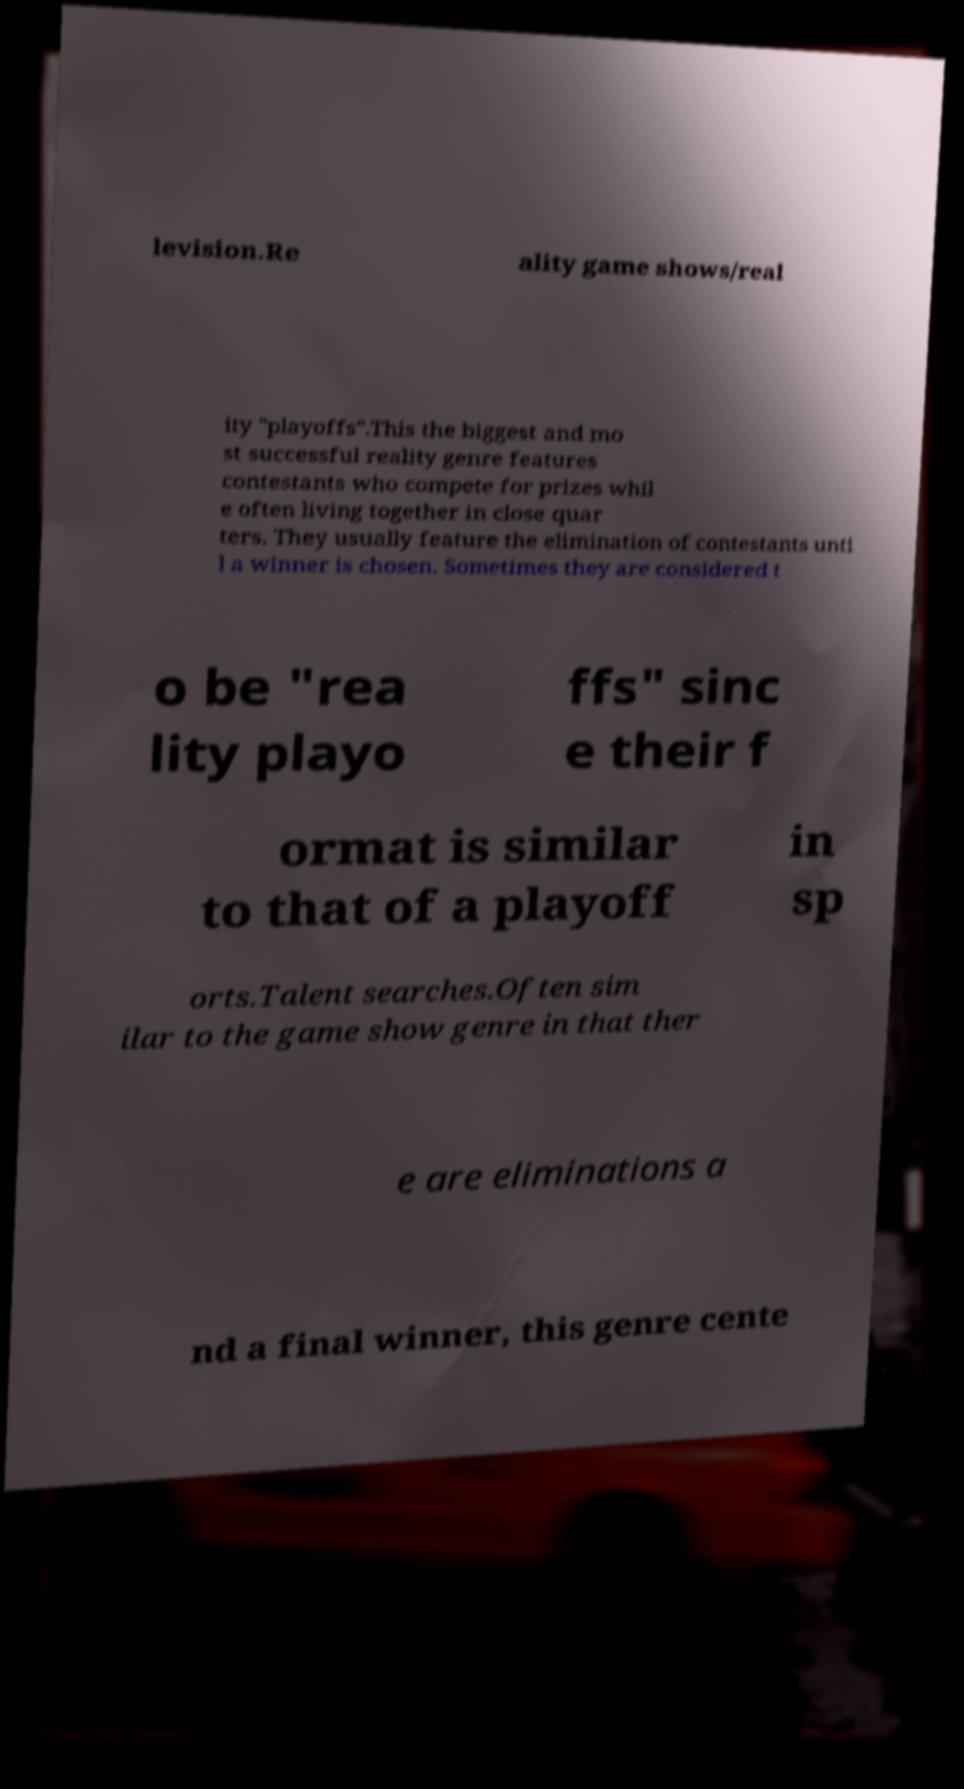Can you accurately transcribe the text from the provided image for me? levision.Re ality game shows/real ity "playoffs".This the biggest and mo st successful reality genre features contestants who compete for prizes whil e often living together in close quar ters. They usually feature the elimination of contestants unti l a winner is chosen. Sometimes they are considered t o be "rea lity playo ffs" sinc e their f ormat is similar to that of a playoff in sp orts.Talent searches.Often sim ilar to the game show genre in that ther e are eliminations a nd a final winner, this genre cente 